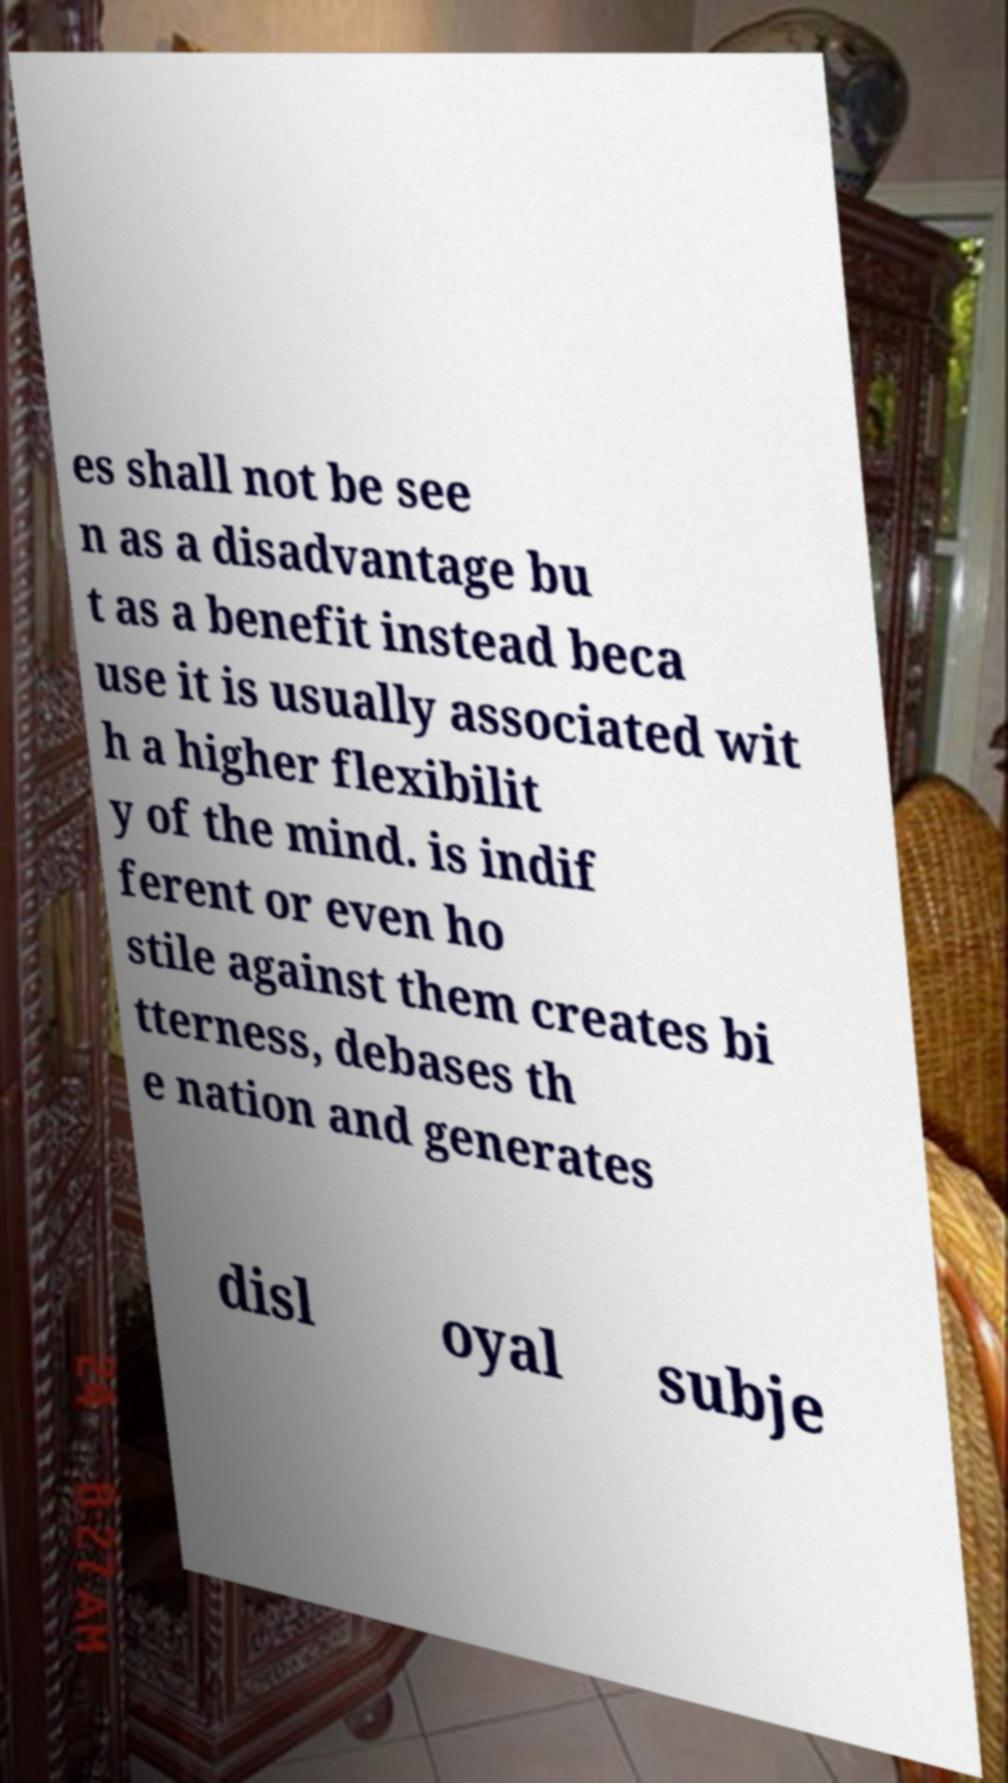Could you assist in decoding the text presented in this image and type it out clearly? es shall not be see n as a disadvantage bu t as a benefit instead beca use it is usually associated wit h a higher flexibilit y of the mind. is indif ferent or even ho stile against them creates bi tterness, debases th e nation and generates disl oyal subje 